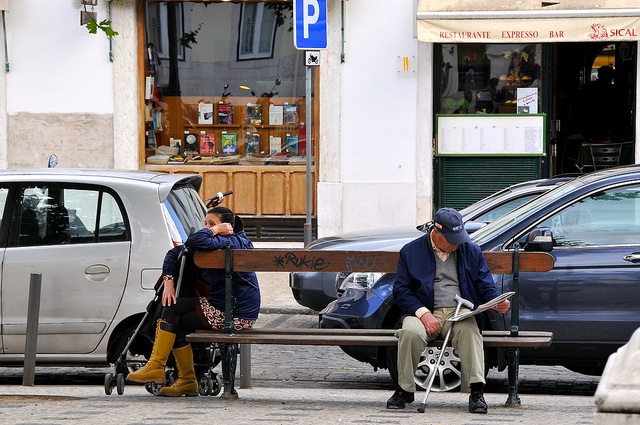Describe the objects in this image and their specific colors. I can see car in lightgray, darkgray, black, and gray tones, car in lightgray, black, gray, and darkgray tones, bench in lightgray, black, maroon, gray, and darkgray tones, people in lightgray, black, maroon, olive, and navy tones, and people in lightgray, black, gray, navy, and darkgray tones in this image. 